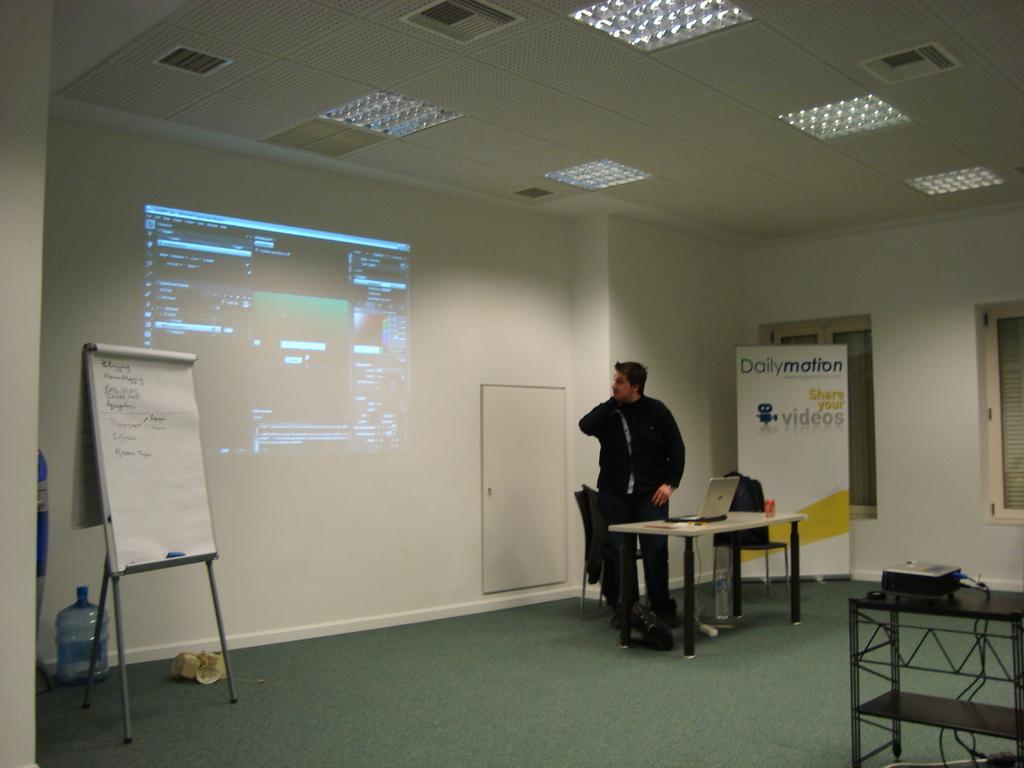What are they asked to share?
Make the answer very short. Videos. 